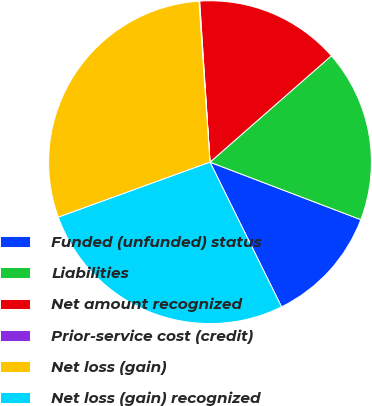<chart> <loc_0><loc_0><loc_500><loc_500><pie_chart><fcel>Funded (unfunded) status<fcel>Liabilities<fcel>Net amount recognized<fcel>Prior-service cost (credit)<fcel>Net loss (gain)<fcel>Net loss (gain) recognized<nl><fcel>11.9%<fcel>17.25%<fcel>14.57%<fcel>0.07%<fcel>29.45%<fcel>26.77%<nl></chart> 